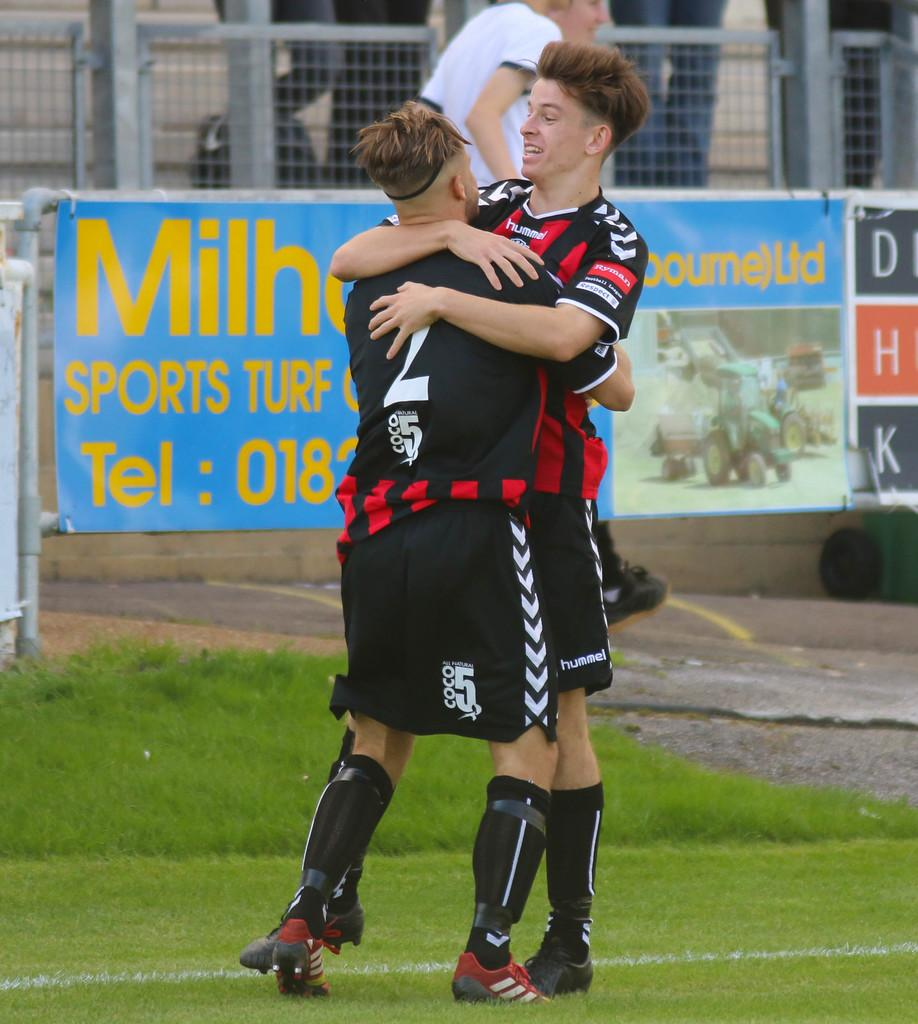Provide a one-sentence caption for the provided image. Two soccer players hug each other in front of an ad for a Sports Turf business. 